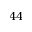Convert formula to latex. <formula><loc_0><loc_0><loc_500><loc_500>4 4</formula> 